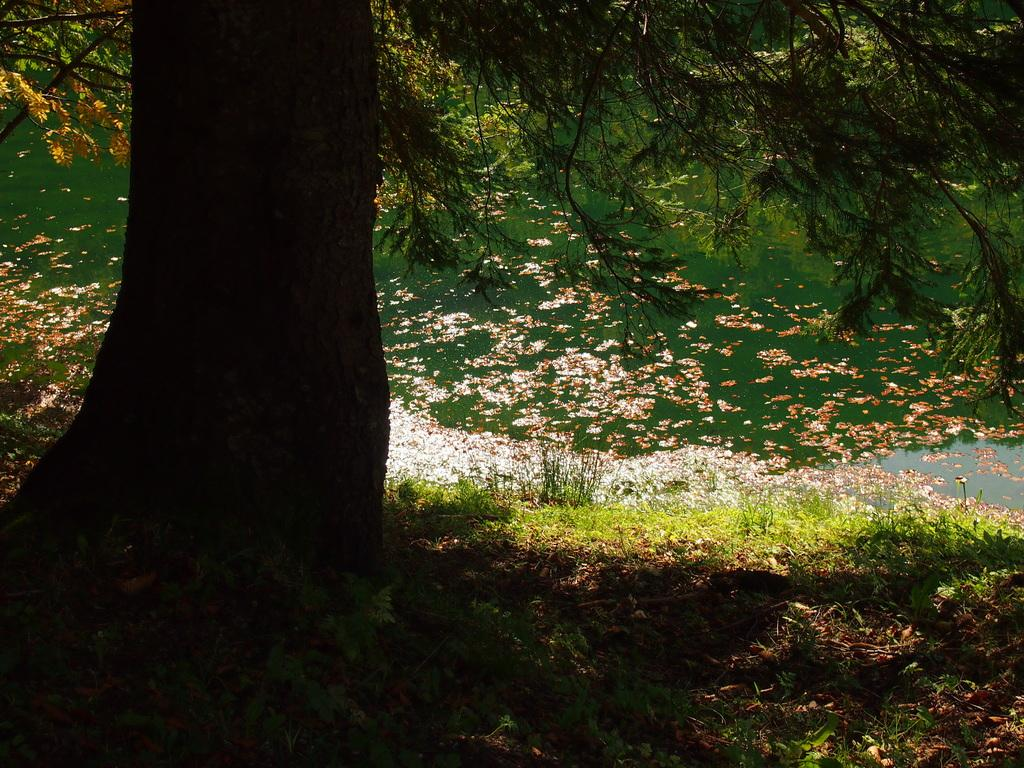What type of plant is on the left side of the image? There is a tree with green leaves on the left side of the image. What is the ground beneath the tree covered with? There is grass on the ground beneath the tree. What can be seen in the background of the image? In the background, there are dry leaves. What else is present in the background of the image? There are flowers visible in the water in the background. What type of coat is the tree wearing in the image? Trees do not wear coats, so this question is not applicable to the image. 